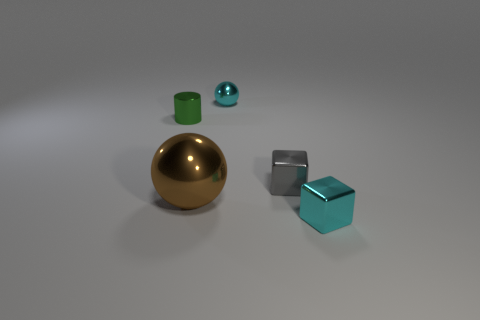Add 4 red metal blocks. How many objects exist? 9 Subtract all cylinders. How many objects are left? 4 Add 2 cyan objects. How many cyan objects exist? 4 Subtract 0 yellow spheres. How many objects are left? 5 Subtract all tiny green blocks. Subtract all brown metallic objects. How many objects are left? 4 Add 1 cyan metal objects. How many cyan metal objects are left? 3 